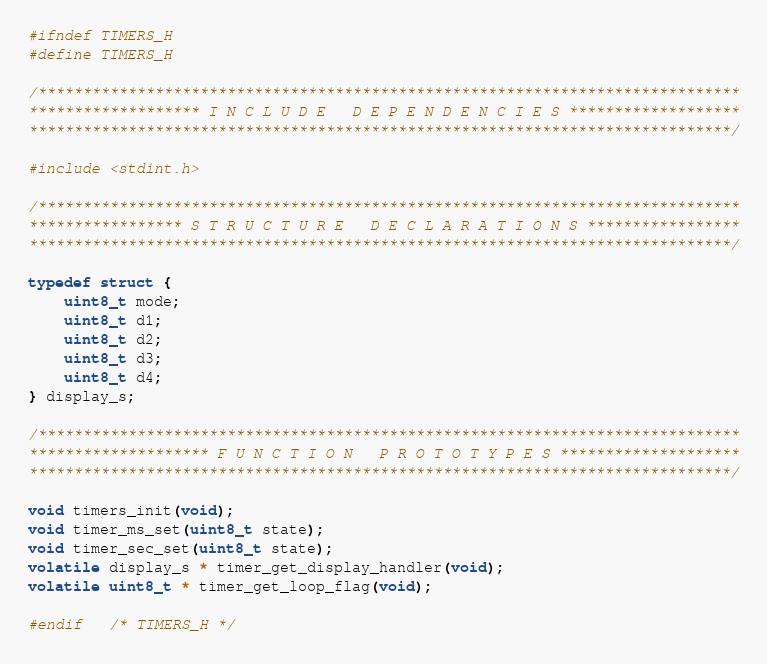Convert code to text. <code><loc_0><loc_0><loc_500><loc_500><_C_>
#ifndef TIMERS_H
#define TIMERS_H

/******************************************************************************
*******************	I N C L U D E   D E P E N D E N C I E S	*******************
******************************************************************************/

#include <stdint.h>

/******************************************************************************
***************** S T R U C T U R E   D E C L A R A T I O N S *****************
******************************************************************************/

typedef struct {
    uint8_t mode;
    uint8_t d1;
    uint8_t d2;
    uint8_t d3;
    uint8_t d4;
} display_s;

/******************************************************************************
******************** F U N C T I O N   P R O T O T Y P E S ********************
******************************************************************************/

void timers_init(void);
void timer_ms_set(uint8_t state);
void timer_sec_set(uint8_t state);
volatile display_s * timer_get_display_handler(void);
volatile uint8_t * timer_get_loop_flag(void);

#endif 	/* TIMERS_H */</code> 